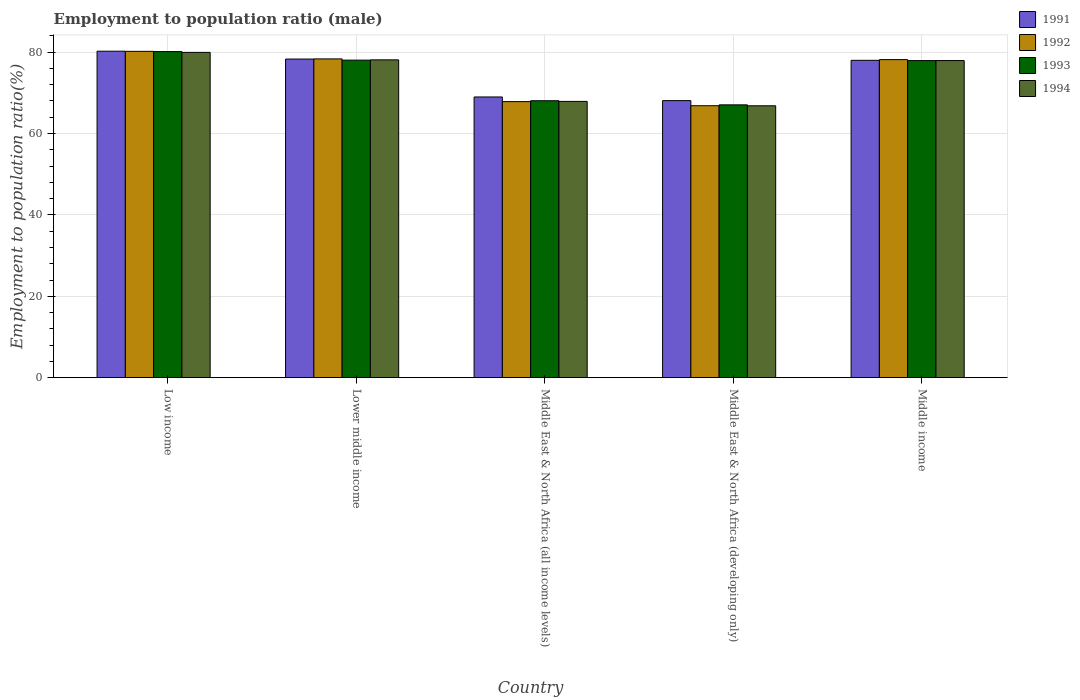How many different coloured bars are there?
Your answer should be very brief. 4. How many groups of bars are there?
Make the answer very short. 5. Are the number of bars per tick equal to the number of legend labels?
Provide a short and direct response. Yes. Are the number of bars on each tick of the X-axis equal?
Offer a terse response. Yes. How many bars are there on the 2nd tick from the left?
Offer a very short reply. 4. How many bars are there on the 2nd tick from the right?
Your answer should be compact. 4. What is the label of the 3rd group of bars from the left?
Your answer should be very brief. Middle East & North Africa (all income levels). In how many cases, is the number of bars for a given country not equal to the number of legend labels?
Offer a very short reply. 0. What is the employment to population ratio in 1994 in Middle East & North Africa (all income levels)?
Your response must be concise. 67.9. Across all countries, what is the maximum employment to population ratio in 1992?
Make the answer very short. 80.2. Across all countries, what is the minimum employment to population ratio in 1991?
Your response must be concise. 68.09. In which country was the employment to population ratio in 1993 maximum?
Offer a very short reply. Low income. In which country was the employment to population ratio in 1993 minimum?
Your answer should be very brief. Middle East & North Africa (developing only). What is the total employment to population ratio in 1993 in the graph?
Your response must be concise. 371.21. What is the difference between the employment to population ratio in 1992 in Middle East & North Africa (developing only) and that in Middle income?
Keep it short and to the point. -11.33. What is the difference between the employment to population ratio in 1994 in Middle East & North Africa (all income levels) and the employment to population ratio in 1992 in Lower middle income?
Your answer should be very brief. -10.44. What is the average employment to population ratio in 1994 per country?
Provide a succinct answer. 74.14. What is the difference between the employment to population ratio of/in 1993 and employment to population ratio of/in 1991 in Middle East & North Africa (all income levels)?
Ensure brevity in your answer.  -0.93. In how many countries, is the employment to population ratio in 1992 greater than 40 %?
Ensure brevity in your answer.  5. What is the ratio of the employment to population ratio in 1994 in Lower middle income to that in Middle East & North Africa (all income levels)?
Your answer should be very brief. 1.15. What is the difference between the highest and the second highest employment to population ratio in 1994?
Provide a succinct answer. -0.18. What is the difference between the highest and the lowest employment to population ratio in 1994?
Your answer should be very brief. 13.12. Is the sum of the employment to population ratio in 1992 in Low income and Lower middle income greater than the maximum employment to population ratio in 1993 across all countries?
Keep it short and to the point. Yes. Is it the case that in every country, the sum of the employment to population ratio in 1994 and employment to population ratio in 1992 is greater than the sum of employment to population ratio in 1993 and employment to population ratio in 1991?
Offer a terse response. No. What does the 1st bar from the right in Lower middle income represents?
Give a very brief answer. 1994. What is the difference between two consecutive major ticks on the Y-axis?
Your response must be concise. 20. Are the values on the major ticks of Y-axis written in scientific E-notation?
Ensure brevity in your answer.  No. Where does the legend appear in the graph?
Offer a very short reply. Top right. What is the title of the graph?
Make the answer very short. Employment to population ratio (male). What is the label or title of the Y-axis?
Provide a succinct answer. Employment to population ratio(%). What is the Employment to population ratio(%) in 1991 in Low income?
Ensure brevity in your answer.  80.23. What is the Employment to population ratio(%) of 1992 in Low income?
Make the answer very short. 80.2. What is the Employment to population ratio(%) of 1993 in Low income?
Keep it short and to the point. 80.14. What is the Employment to population ratio(%) of 1994 in Low income?
Keep it short and to the point. 79.94. What is the Employment to population ratio(%) in 1991 in Lower middle income?
Your response must be concise. 78.3. What is the Employment to population ratio(%) in 1992 in Lower middle income?
Your response must be concise. 78.34. What is the Employment to population ratio(%) of 1993 in Lower middle income?
Your response must be concise. 78.04. What is the Employment to population ratio(%) in 1994 in Lower middle income?
Ensure brevity in your answer.  78.11. What is the Employment to population ratio(%) of 1991 in Middle East & North Africa (all income levels)?
Offer a very short reply. 68.99. What is the Employment to population ratio(%) in 1992 in Middle East & North Africa (all income levels)?
Provide a succinct answer. 67.84. What is the Employment to population ratio(%) in 1993 in Middle East & North Africa (all income levels)?
Your answer should be very brief. 68.06. What is the Employment to population ratio(%) of 1994 in Middle East & North Africa (all income levels)?
Your response must be concise. 67.9. What is the Employment to population ratio(%) of 1991 in Middle East & North Africa (developing only)?
Keep it short and to the point. 68.09. What is the Employment to population ratio(%) in 1992 in Middle East & North Africa (developing only)?
Your response must be concise. 66.83. What is the Employment to population ratio(%) of 1993 in Middle East & North Africa (developing only)?
Ensure brevity in your answer.  67.05. What is the Employment to population ratio(%) of 1994 in Middle East & North Africa (developing only)?
Provide a short and direct response. 66.82. What is the Employment to population ratio(%) in 1991 in Middle income?
Provide a short and direct response. 77.99. What is the Employment to population ratio(%) of 1992 in Middle income?
Your answer should be compact. 78.16. What is the Employment to population ratio(%) of 1993 in Middle income?
Offer a very short reply. 77.93. What is the Employment to population ratio(%) in 1994 in Middle income?
Give a very brief answer. 77.93. Across all countries, what is the maximum Employment to population ratio(%) in 1991?
Ensure brevity in your answer.  80.23. Across all countries, what is the maximum Employment to population ratio(%) in 1992?
Offer a terse response. 80.2. Across all countries, what is the maximum Employment to population ratio(%) in 1993?
Ensure brevity in your answer.  80.14. Across all countries, what is the maximum Employment to population ratio(%) in 1994?
Make the answer very short. 79.94. Across all countries, what is the minimum Employment to population ratio(%) in 1991?
Your answer should be very brief. 68.09. Across all countries, what is the minimum Employment to population ratio(%) in 1992?
Provide a short and direct response. 66.83. Across all countries, what is the minimum Employment to population ratio(%) of 1993?
Offer a very short reply. 67.05. Across all countries, what is the minimum Employment to population ratio(%) in 1994?
Keep it short and to the point. 66.82. What is the total Employment to population ratio(%) of 1991 in the graph?
Give a very brief answer. 373.6. What is the total Employment to population ratio(%) in 1992 in the graph?
Your answer should be compact. 371.38. What is the total Employment to population ratio(%) of 1993 in the graph?
Make the answer very short. 371.21. What is the total Employment to population ratio(%) in 1994 in the graph?
Offer a terse response. 370.69. What is the difference between the Employment to population ratio(%) of 1991 in Low income and that in Lower middle income?
Ensure brevity in your answer.  1.93. What is the difference between the Employment to population ratio(%) of 1992 in Low income and that in Lower middle income?
Your answer should be compact. 1.86. What is the difference between the Employment to population ratio(%) in 1993 in Low income and that in Lower middle income?
Ensure brevity in your answer.  2.1. What is the difference between the Employment to population ratio(%) of 1994 in Low income and that in Lower middle income?
Your response must be concise. 1.84. What is the difference between the Employment to population ratio(%) in 1991 in Low income and that in Middle East & North Africa (all income levels)?
Give a very brief answer. 11.25. What is the difference between the Employment to population ratio(%) of 1992 in Low income and that in Middle East & North Africa (all income levels)?
Your response must be concise. 12.36. What is the difference between the Employment to population ratio(%) of 1993 in Low income and that in Middle East & North Africa (all income levels)?
Offer a terse response. 12.08. What is the difference between the Employment to population ratio(%) of 1994 in Low income and that in Middle East & North Africa (all income levels)?
Offer a terse response. 12.04. What is the difference between the Employment to population ratio(%) in 1991 in Low income and that in Middle East & North Africa (developing only)?
Offer a very short reply. 12.14. What is the difference between the Employment to population ratio(%) in 1992 in Low income and that in Middle East & North Africa (developing only)?
Your answer should be very brief. 13.37. What is the difference between the Employment to population ratio(%) of 1993 in Low income and that in Middle East & North Africa (developing only)?
Your answer should be compact. 13.09. What is the difference between the Employment to population ratio(%) of 1994 in Low income and that in Middle East & North Africa (developing only)?
Your answer should be very brief. 13.12. What is the difference between the Employment to population ratio(%) in 1991 in Low income and that in Middle income?
Offer a terse response. 2.24. What is the difference between the Employment to population ratio(%) of 1992 in Low income and that in Middle income?
Offer a terse response. 2.04. What is the difference between the Employment to population ratio(%) of 1993 in Low income and that in Middle income?
Your response must be concise. 2.21. What is the difference between the Employment to population ratio(%) in 1994 in Low income and that in Middle income?
Make the answer very short. 2.01. What is the difference between the Employment to population ratio(%) in 1991 in Lower middle income and that in Middle East & North Africa (all income levels)?
Offer a terse response. 9.32. What is the difference between the Employment to population ratio(%) of 1992 in Lower middle income and that in Middle East & North Africa (all income levels)?
Keep it short and to the point. 10.5. What is the difference between the Employment to population ratio(%) of 1993 in Lower middle income and that in Middle East & North Africa (all income levels)?
Your answer should be compact. 9.98. What is the difference between the Employment to population ratio(%) of 1994 in Lower middle income and that in Middle East & North Africa (all income levels)?
Give a very brief answer. 10.21. What is the difference between the Employment to population ratio(%) of 1991 in Lower middle income and that in Middle East & North Africa (developing only)?
Offer a very short reply. 10.21. What is the difference between the Employment to population ratio(%) in 1992 in Lower middle income and that in Middle East & North Africa (developing only)?
Your answer should be very brief. 11.51. What is the difference between the Employment to population ratio(%) in 1993 in Lower middle income and that in Middle East & North Africa (developing only)?
Keep it short and to the point. 10.99. What is the difference between the Employment to population ratio(%) of 1994 in Lower middle income and that in Middle East & North Africa (developing only)?
Your response must be concise. 11.29. What is the difference between the Employment to population ratio(%) of 1991 in Lower middle income and that in Middle income?
Your response must be concise. 0.31. What is the difference between the Employment to population ratio(%) of 1992 in Lower middle income and that in Middle income?
Provide a succinct answer. 0.18. What is the difference between the Employment to population ratio(%) of 1993 in Lower middle income and that in Middle income?
Give a very brief answer. 0.11. What is the difference between the Employment to population ratio(%) in 1994 in Lower middle income and that in Middle income?
Ensure brevity in your answer.  0.18. What is the difference between the Employment to population ratio(%) of 1991 in Middle East & North Africa (all income levels) and that in Middle East & North Africa (developing only)?
Offer a terse response. 0.9. What is the difference between the Employment to population ratio(%) of 1992 in Middle East & North Africa (all income levels) and that in Middle East & North Africa (developing only)?
Provide a short and direct response. 1.01. What is the difference between the Employment to population ratio(%) in 1993 in Middle East & North Africa (all income levels) and that in Middle East & North Africa (developing only)?
Give a very brief answer. 1.01. What is the difference between the Employment to population ratio(%) of 1994 in Middle East & North Africa (all income levels) and that in Middle East & North Africa (developing only)?
Offer a very short reply. 1.08. What is the difference between the Employment to population ratio(%) in 1991 in Middle East & North Africa (all income levels) and that in Middle income?
Provide a succinct answer. -9. What is the difference between the Employment to population ratio(%) in 1992 in Middle East & North Africa (all income levels) and that in Middle income?
Give a very brief answer. -10.32. What is the difference between the Employment to population ratio(%) in 1993 in Middle East & North Africa (all income levels) and that in Middle income?
Ensure brevity in your answer.  -9.87. What is the difference between the Employment to population ratio(%) of 1994 in Middle East & North Africa (all income levels) and that in Middle income?
Make the answer very short. -10.03. What is the difference between the Employment to population ratio(%) of 1992 in Middle East & North Africa (developing only) and that in Middle income?
Provide a short and direct response. -11.33. What is the difference between the Employment to population ratio(%) of 1993 in Middle East & North Africa (developing only) and that in Middle income?
Make the answer very short. -10.88. What is the difference between the Employment to population ratio(%) in 1994 in Middle East & North Africa (developing only) and that in Middle income?
Make the answer very short. -11.11. What is the difference between the Employment to population ratio(%) of 1991 in Low income and the Employment to population ratio(%) of 1992 in Lower middle income?
Your response must be concise. 1.89. What is the difference between the Employment to population ratio(%) in 1991 in Low income and the Employment to population ratio(%) in 1993 in Lower middle income?
Give a very brief answer. 2.2. What is the difference between the Employment to population ratio(%) in 1991 in Low income and the Employment to population ratio(%) in 1994 in Lower middle income?
Your answer should be very brief. 2.13. What is the difference between the Employment to population ratio(%) of 1992 in Low income and the Employment to population ratio(%) of 1993 in Lower middle income?
Provide a short and direct response. 2.16. What is the difference between the Employment to population ratio(%) of 1992 in Low income and the Employment to population ratio(%) of 1994 in Lower middle income?
Give a very brief answer. 2.1. What is the difference between the Employment to population ratio(%) in 1993 in Low income and the Employment to population ratio(%) in 1994 in Lower middle income?
Offer a terse response. 2.03. What is the difference between the Employment to population ratio(%) of 1991 in Low income and the Employment to population ratio(%) of 1992 in Middle East & North Africa (all income levels)?
Offer a very short reply. 12.39. What is the difference between the Employment to population ratio(%) in 1991 in Low income and the Employment to population ratio(%) in 1993 in Middle East & North Africa (all income levels)?
Make the answer very short. 12.17. What is the difference between the Employment to population ratio(%) of 1991 in Low income and the Employment to population ratio(%) of 1994 in Middle East & North Africa (all income levels)?
Provide a short and direct response. 12.33. What is the difference between the Employment to population ratio(%) of 1992 in Low income and the Employment to population ratio(%) of 1993 in Middle East & North Africa (all income levels)?
Offer a terse response. 12.14. What is the difference between the Employment to population ratio(%) in 1992 in Low income and the Employment to population ratio(%) in 1994 in Middle East & North Africa (all income levels)?
Provide a short and direct response. 12.3. What is the difference between the Employment to population ratio(%) in 1993 in Low income and the Employment to population ratio(%) in 1994 in Middle East & North Africa (all income levels)?
Your answer should be compact. 12.24. What is the difference between the Employment to population ratio(%) in 1991 in Low income and the Employment to population ratio(%) in 1992 in Middle East & North Africa (developing only)?
Keep it short and to the point. 13.4. What is the difference between the Employment to population ratio(%) in 1991 in Low income and the Employment to population ratio(%) in 1993 in Middle East & North Africa (developing only)?
Your answer should be compact. 13.19. What is the difference between the Employment to population ratio(%) of 1991 in Low income and the Employment to population ratio(%) of 1994 in Middle East & North Africa (developing only)?
Your answer should be very brief. 13.42. What is the difference between the Employment to population ratio(%) of 1992 in Low income and the Employment to population ratio(%) of 1993 in Middle East & North Africa (developing only)?
Keep it short and to the point. 13.15. What is the difference between the Employment to population ratio(%) in 1992 in Low income and the Employment to population ratio(%) in 1994 in Middle East & North Africa (developing only)?
Your response must be concise. 13.38. What is the difference between the Employment to population ratio(%) of 1993 in Low income and the Employment to population ratio(%) of 1994 in Middle East & North Africa (developing only)?
Keep it short and to the point. 13.32. What is the difference between the Employment to population ratio(%) of 1991 in Low income and the Employment to population ratio(%) of 1992 in Middle income?
Keep it short and to the point. 2.07. What is the difference between the Employment to population ratio(%) of 1991 in Low income and the Employment to population ratio(%) of 1993 in Middle income?
Give a very brief answer. 2.31. What is the difference between the Employment to population ratio(%) of 1991 in Low income and the Employment to population ratio(%) of 1994 in Middle income?
Offer a terse response. 2.3. What is the difference between the Employment to population ratio(%) in 1992 in Low income and the Employment to population ratio(%) in 1993 in Middle income?
Ensure brevity in your answer.  2.28. What is the difference between the Employment to population ratio(%) of 1992 in Low income and the Employment to population ratio(%) of 1994 in Middle income?
Provide a succinct answer. 2.27. What is the difference between the Employment to population ratio(%) in 1993 in Low income and the Employment to population ratio(%) in 1994 in Middle income?
Offer a terse response. 2.21. What is the difference between the Employment to population ratio(%) in 1991 in Lower middle income and the Employment to population ratio(%) in 1992 in Middle East & North Africa (all income levels)?
Provide a short and direct response. 10.46. What is the difference between the Employment to population ratio(%) in 1991 in Lower middle income and the Employment to population ratio(%) in 1993 in Middle East & North Africa (all income levels)?
Offer a very short reply. 10.24. What is the difference between the Employment to population ratio(%) in 1991 in Lower middle income and the Employment to population ratio(%) in 1994 in Middle East & North Africa (all income levels)?
Offer a terse response. 10.41. What is the difference between the Employment to population ratio(%) in 1992 in Lower middle income and the Employment to population ratio(%) in 1993 in Middle East & North Africa (all income levels)?
Ensure brevity in your answer.  10.28. What is the difference between the Employment to population ratio(%) in 1992 in Lower middle income and the Employment to population ratio(%) in 1994 in Middle East & North Africa (all income levels)?
Provide a succinct answer. 10.44. What is the difference between the Employment to population ratio(%) in 1993 in Lower middle income and the Employment to population ratio(%) in 1994 in Middle East & North Africa (all income levels)?
Ensure brevity in your answer.  10.14. What is the difference between the Employment to population ratio(%) in 1991 in Lower middle income and the Employment to population ratio(%) in 1992 in Middle East & North Africa (developing only)?
Offer a very short reply. 11.47. What is the difference between the Employment to population ratio(%) in 1991 in Lower middle income and the Employment to population ratio(%) in 1993 in Middle East & North Africa (developing only)?
Your response must be concise. 11.26. What is the difference between the Employment to population ratio(%) in 1991 in Lower middle income and the Employment to population ratio(%) in 1994 in Middle East & North Africa (developing only)?
Your answer should be very brief. 11.49. What is the difference between the Employment to population ratio(%) of 1992 in Lower middle income and the Employment to population ratio(%) of 1993 in Middle East & North Africa (developing only)?
Offer a terse response. 11.29. What is the difference between the Employment to population ratio(%) of 1992 in Lower middle income and the Employment to population ratio(%) of 1994 in Middle East & North Africa (developing only)?
Offer a terse response. 11.52. What is the difference between the Employment to population ratio(%) in 1993 in Lower middle income and the Employment to population ratio(%) in 1994 in Middle East & North Africa (developing only)?
Your answer should be compact. 11.22. What is the difference between the Employment to population ratio(%) in 1991 in Lower middle income and the Employment to population ratio(%) in 1992 in Middle income?
Make the answer very short. 0.14. What is the difference between the Employment to population ratio(%) of 1991 in Lower middle income and the Employment to population ratio(%) of 1993 in Middle income?
Offer a terse response. 0.38. What is the difference between the Employment to population ratio(%) in 1991 in Lower middle income and the Employment to population ratio(%) in 1994 in Middle income?
Provide a short and direct response. 0.38. What is the difference between the Employment to population ratio(%) of 1992 in Lower middle income and the Employment to population ratio(%) of 1993 in Middle income?
Give a very brief answer. 0.42. What is the difference between the Employment to population ratio(%) in 1992 in Lower middle income and the Employment to population ratio(%) in 1994 in Middle income?
Keep it short and to the point. 0.41. What is the difference between the Employment to population ratio(%) in 1993 in Lower middle income and the Employment to population ratio(%) in 1994 in Middle income?
Your answer should be compact. 0.11. What is the difference between the Employment to population ratio(%) in 1991 in Middle East & North Africa (all income levels) and the Employment to population ratio(%) in 1992 in Middle East & North Africa (developing only)?
Keep it short and to the point. 2.15. What is the difference between the Employment to population ratio(%) of 1991 in Middle East & North Africa (all income levels) and the Employment to population ratio(%) of 1993 in Middle East & North Africa (developing only)?
Ensure brevity in your answer.  1.94. What is the difference between the Employment to population ratio(%) of 1991 in Middle East & North Africa (all income levels) and the Employment to population ratio(%) of 1994 in Middle East & North Africa (developing only)?
Make the answer very short. 2.17. What is the difference between the Employment to population ratio(%) of 1992 in Middle East & North Africa (all income levels) and the Employment to population ratio(%) of 1993 in Middle East & North Africa (developing only)?
Your answer should be very brief. 0.79. What is the difference between the Employment to population ratio(%) of 1992 in Middle East & North Africa (all income levels) and the Employment to population ratio(%) of 1994 in Middle East & North Africa (developing only)?
Provide a succinct answer. 1.02. What is the difference between the Employment to population ratio(%) in 1993 in Middle East & North Africa (all income levels) and the Employment to population ratio(%) in 1994 in Middle East & North Africa (developing only)?
Offer a very short reply. 1.24. What is the difference between the Employment to population ratio(%) of 1991 in Middle East & North Africa (all income levels) and the Employment to population ratio(%) of 1992 in Middle income?
Provide a short and direct response. -9.18. What is the difference between the Employment to population ratio(%) of 1991 in Middle East & North Africa (all income levels) and the Employment to population ratio(%) of 1993 in Middle income?
Your answer should be very brief. -8.94. What is the difference between the Employment to population ratio(%) of 1991 in Middle East & North Africa (all income levels) and the Employment to population ratio(%) of 1994 in Middle income?
Offer a very short reply. -8.94. What is the difference between the Employment to population ratio(%) in 1992 in Middle East & North Africa (all income levels) and the Employment to population ratio(%) in 1993 in Middle income?
Provide a succinct answer. -10.08. What is the difference between the Employment to population ratio(%) of 1992 in Middle East & North Africa (all income levels) and the Employment to population ratio(%) of 1994 in Middle income?
Offer a terse response. -10.09. What is the difference between the Employment to population ratio(%) of 1993 in Middle East & North Africa (all income levels) and the Employment to population ratio(%) of 1994 in Middle income?
Keep it short and to the point. -9.87. What is the difference between the Employment to population ratio(%) of 1991 in Middle East & North Africa (developing only) and the Employment to population ratio(%) of 1992 in Middle income?
Offer a very short reply. -10.07. What is the difference between the Employment to population ratio(%) in 1991 in Middle East & North Africa (developing only) and the Employment to population ratio(%) in 1993 in Middle income?
Keep it short and to the point. -9.84. What is the difference between the Employment to population ratio(%) in 1991 in Middle East & North Africa (developing only) and the Employment to population ratio(%) in 1994 in Middle income?
Offer a terse response. -9.84. What is the difference between the Employment to population ratio(%) of 1992 in Middle East & North Africa (developing only) and the Employment to population ratio(%) of 1993 in Middle income?
Make the answer very short. -11.09. What is the difference between the Employment to population ratio(%) in 1992 in Middle East & North Africa (developing only) and the Employment to population ratio(%) in 1994 in Middle income?
Give a very brief answer. -11.1. What is the difference between the Employment to population ratio(%) of 1993 in Middle East & North Africa (developing only) and the Employment to population ratio(%) of 1994 in Middle income?
Your response must be concise. -10.88. What is the average Employment to population ratio(%) of 1991 per country?
Make the answer very short. 74.72. What is the average Employment to population ratio(%) of 1992 per country?
Provide a succinct answer. 74.28. What is the average Employment to population ratio(%) of 1993 per country?
Your answer should be very brief. 74.24. What is the average Employment to population ratio(%) in 1994 per country?
Keep it short and to the point. 74.14. What is the difference between the Employment to population ratio(%) in 1991 and Employment to population ratio(%) in 1992 in Low income?
Ensure brevity in your answer.  0.03. What is the difference between the Employment to population ratio(%) in 1991 and Employment to population ratio(%) in 1993 in Low income?
Make the answer very short. 0.1. What is the difference between the Employment to population ratio(%) of 1991 and Employment to population ratio(%) of 1994 in Low income?
Make the answer very short. 0.29. What is the difference between the Employment to population ratio(%) of 1992 and Employment to population ratio(%) of 1993 in Low income?
Your response must be concise. 0.06. What is the difference between the Employment to population ratio(%) of 1992 and Employment to population ratio(%) of 1994 in Low income?
Give a very brief answer. 0.26. What is the difference between the Employment to population ratio(%) of 1993 and Employment to population ratio(%) of 1994 in Low income?
Keep it short and to the point. 0.19. What is the difference between the Employment to population ratio(%) of 1991 and Employment to population ratio(%) of 1992 in Lower middle income?
Your response must be concise. -0.04. What is the difference between the Employment to population ratio(%) of 1991 and Employment to population ratio(%) of 1993 in Lower middle income?
Ensure brevity in your answer.  0.27. What is the difference between the Employment to population ratio(%) in 1991 and Employment to population ratio(%) in 1994 in Lower middle income?
Make the answer very short. 0.2. What is the difference between the Employment to population ratio(%) of 1992 and Employment to population ratio(%) of 1993 in Lower middle income?
Provide a short and direct response. 0.3. What is the difference between the Employment to population ratio(%) of 1992 and Employment to population ratio(%) of 1994 in Lower middle income?
Give a very brief answer. 0.24. What is the difference between the Employment to population ratio(%) of 1993 and Employment to population ratio(%) of 1994 in Lower middle income?
Provide a short and direct response. -0.07. What is the difference between the Employment to population ratio(%) of 1991 and Employment to population ratio(%) of 1992 in Middle East & North Africa (all income levels)?
Offer a very short reply. 1.14. What is the difference between the Employment to population ratio(%) in 1991 and Employment to population ratio(%) in 1993 in Middle East & North Africa (all income levels)?
Provide a succinct answer. 0.93. What is the difference between the Employment to population ratio(%) of 1991 and Employment to population ratio(%) of 1994 in Middle East & North Africa (all income levels)?
Your answer should be compact. 1.09. What is the difference between the Employment to population ratio(%) in 1992 and Employment to population ratio(%) in 1993 in Middle East & North Africa (all income levels)?
Give a very brief answer. -0.22. What is the difference between the Employment to population ratio(%) of 1992 and Employment to population ratio(%) of 1994 in Middle East & North Africa (all income levels)?
Provide a short and direct response. -0.06. What is the difference between the Employment to population ratio(%) in 1993 and Employment to population ratio(%) in 1994 in Middle East & North Africa (all income levels)?
Give a very brief answer. 0.16. What is the difference between the Employment to population ratio(%) of 1991 and Employment to population ratio(%) of 1992 in Middle East & North Africa (developing only)?
Offer a terse response. 1.26. What is the difference between the Employment to population ratio(%) of 1991 and Employment to population ratio(%) of 1993 in Middle East & North Africa (developing only)?
Ensure brevity in your answer.  1.04. What is the difference between the Employment to population ratio(%) in 1991 and Employment to population ratio(%) in 1994 in Middle East & North Africa (developing only)?
Ensure brevity in your answer.  1.27. What is the difference between the Employment to population ratio(%) of 1992 and Employment to population ratio(%) of 1993 in Middle East & North Africa (developing only)?
Give a very brief answer. -0.21. What is the difference between the Employment to population ratio(%) in 1992 and Employment to population ratio(%) in 1994 in Middle East & North Africa (developing only)?
Offer a very short reply. 0.01. What is the difference between the Employment to population ratio(%) in 1993 and Employment to population ratio(%) in 1994 in Middle East & North Africa (developing only)?
Keep it short and to the point. 0.23. What is the difference between the Employment to population ratio(%) of 1991 and Employment to population ratio(%) of 1992 in Middle income?
Make the answer very short. -0.17. What is the difference between the Employment to population ratio(%) in 1991 and Employment to population ratio(%) in 1993 in Middle income?
Offer a terse response. 0.06. What is the difference between the Employment to population ratio(%) in 1991 and Employment to population ratio(%) in 1994 in Middle income?
Make the answer very short. 0.06. What is the difference between the Employment to population ratio(%) of 1992 and Employment to population ratio(%) of 1993 in Middle income?
Your response must be concise. 0.24. What is the difference between the Employment to population ratio(%) in 1992 and Employment to population ratio(%) in 1994 in Middle income?
Provide a succinct answer. 0.23. What is the difference between the Employment to population ratio(%) of 1993 and Employment to population ratio(%) of 1994 in Middle income?
Make the answer very short. -0. What is the ratio of the Employment to population ratio(%) of 1991 in Low income to that in Lower middle income?
Ensure brevity in your answer.  1.02. What is the ratio of the Employment to population ratio(%) in 1992 in Low income to that in Lower middle income?
Give a very brief answer. 1.02. What is the ratio of the Employment to population ratio(%) in 1993 in Low income to that in Lower middle income?
Your answer should be compact. 1.03. What is the ratio of the Employment to population ratio(%) in 1994 in Low income to that in Lower middle income?
Provide a short and direct response. 1.02. What is the ratio of the Employment to population ratio(%) in 1991 in Low income to that in Middle East & North Africa (all income levels)?
Your response must be concise. 1.16. What is the ratio of the Employment to population ratio(%) of 1992 in Low income to that in Middle East & North Africa (all income levels)?
Offer a very short reply. 1.18. What is the ratio of the Employment to population ratio(%) of 1993 in Low income to that in Middle East & North Africa (all income levels)?
Provide a short and direct response. 1.18. What is the ratio of the Employment to population ratio(%) in 1994 in Low income to that in Middle East & North Africa (all income levels)?
Provide a succinct answer. 1.18. What is the ratio of the Employment to population ratio(%) in 1991 in Low income to that in Middle East & North Africa (developing only)?
Make the answer very short. 1.18. What is the ratio of the Employment to population ratio(%) of 1992 in Low income to that in Middle East & North Africa (developing only)?
Make the answer very short. 1.2. What is the ratio of the Employment to population ratio(%) in 1993 in Low income to that in Middle East & North Africa (developing only)?
Provide a short and direct response. 1.2. What is the ratio of the Employment to population ratio(%) of 1994 in Low income to that in Middle East & North Africa (developing only)?
Offer a very short reply. 1.2. What is the ratio of the Employment to population ratio(%) of 1991 in Low income to that in Middle income?
Offer a terse response. 1.03. What is the ratio of the Employment to population ratio(%) of 1992 in Low income to that in Middle income?
Offer a terse response. 1.03. What is the ratio of the Employment to population ratio(%) of 1993 in Low income to that in Middle income?
Keep it short and to the point. 1.03. What is the ratio of the Employment to population ratio(%) of 1994 in Low income to that in Middle income?
Offer a very short reply. 1.03. What is the ratio of the Employment to population ratio(%) in 1991 in Lower middle income to that in Middle East & North Africa (all income levels)?
Your answer should be very brief. 1.14. What is the ratio of the Employment to population ratio(%) in 1992 in Lower middle income to that in Middle East & North Africa (all income levels)?
Your answer should be very brief. 1.15. What is the ratio of the Employment to population ratio(%) of 1993 in Lower middle income to that in Middle East & North Africa (all income levels)?
Offer a terse response. 1.15. What is the ratio of the Employment to population ratio(%) of 1994 in Lower middle income to that in Middle East & North Africa (all income levels)?
Give a very brief answer. 1.15. What is the ratio of the Employment to population ratio(%) in 1991 in Lower middle income to that in Middle East & North Africa (developing only)?
Ensure brevity in your answer.  1.15. What is the ratio of the Employment to population ratio(%) of 1992 in Lower middle income to that in Middle East & North Africa (developing only)?
Make the answer very short. 1.17. What is the ratio of the Employment to population ratio(%) in 1993 in Lower middle income to that in Middle East & North Africa (developing only)?
Your answer should be compact. 1.16. What is the ratio of the Employment to population ratio(%) of 1994 in Lower middle income to that in Middle East & North Africa (developing only)?
Give a very brief answer. 1.17. What is the ratio of the Employment to population ratio(%) of 1991 in Lower middle income to that in Middle income?
Your response must be concise. 1. What is the ratio of the Employment to population ratio(%) in 1992 in Lower middle income to that in Middle income?
Ensure brevity in your answer.  1. What is the ratio of the Employment to population ratio(%) of 1991 in Middle East & North Africa (all income levels) to that in Middle East & North Africa (developing only)?
Your answer should be very brief. 1.01. What is the ratio of the Employment to population ratio(%) of 1992 in Middle East & North Africa (all income levels) to that in Middle East & North Africa (developing only)?
Provide a short and direct response. 1.02. What is the ratio of the Employment to population ratio(%) in 1993 in Middle East & North Africa (all income levels) to that in Middle East & North Africa (developing only)?
Ensure brevity in your answer.  1.02. What is the ratio of the Employment to population ratio(%) of 1994 in Middle East & North Africa (all income levels) to that in Middle East & North Africa (developing only)?
Your answer should be compact. 1.02. What is the ratio of the Employment to population ratio(%) of 1991 in Middle East & North Africa (all income levels) to that in Middle income?
Provide a succinct answer. 0.88. What is the ratio of the Employment to population ratio(%) of 1992 in Middle East & North Africa (all income levels) to that in Middle income?
Your answer should be very brief. 0.87. What is the ratio of the Employment to population ratio(%) in 1993 in Middle East & North Africa (all income levels) to that in Middle income?
Ensure brevity in your answer.  0.87. What is the ratio of the Employment to population ratio(%) in 1994 in Middle East & North Africa (all income levels) to that in Middle income?
Keep it short and to the point. 0.87. What is the ratio of the Employment to population ratio(%) in 1991 in Middle East & North Africa (developing only) to that in Middle income?
Keep it short and to the point. 0.87. What is the ratio of the Employment to population ratio(%) of 1992 in Middle East & North Africa (developing only) to that in Middle income?
Give a very brief answer. 0.85. What is the ratio of the Employment to population ratio(%) in 1993 in Middle East & North Africa (developing only) to that in Middle income?
Ensure brevity in your answer.  0.86. What is the ratio of the Employment to population ratio(%) of 1994 in Middle East & North Africa (developing only) to that in Middle income?
Offer a terse response. 0.86. What is the difference between the highest and the second highest Employment to population ratio(%) in 1991?
Make the answer very short. 1.93. What is the difference between the highest and the second highest Employment to population ratio(%) in 1992?
Give a very brief answer. 1.86. What is the difference between the highest and the second highest Employment to population ratio(%) in 1993?
Ensure brevity in your answer.  2.1. What is the difference between the highest and the second highest Employment to population ratio(%) in 1994?
Ensure brevity in your answer.  1.84. What is the difference between the highest and the lowest Employment to population ratio(%) in 1991?
Your response must be concise. 12.14. What is the difference between the highest and the lowest Employment to population ratio(%) of 1992?
Give a very brief answer. 13.37. What is the difference between the highest and the lowest Employment to population ratio(%) of 1993?
Offer a very short reply. 13.09. What is the difference between the highest and the lowest Employment to population ratio(%) of 1994?
Provide a short and direct response. 13.12. 